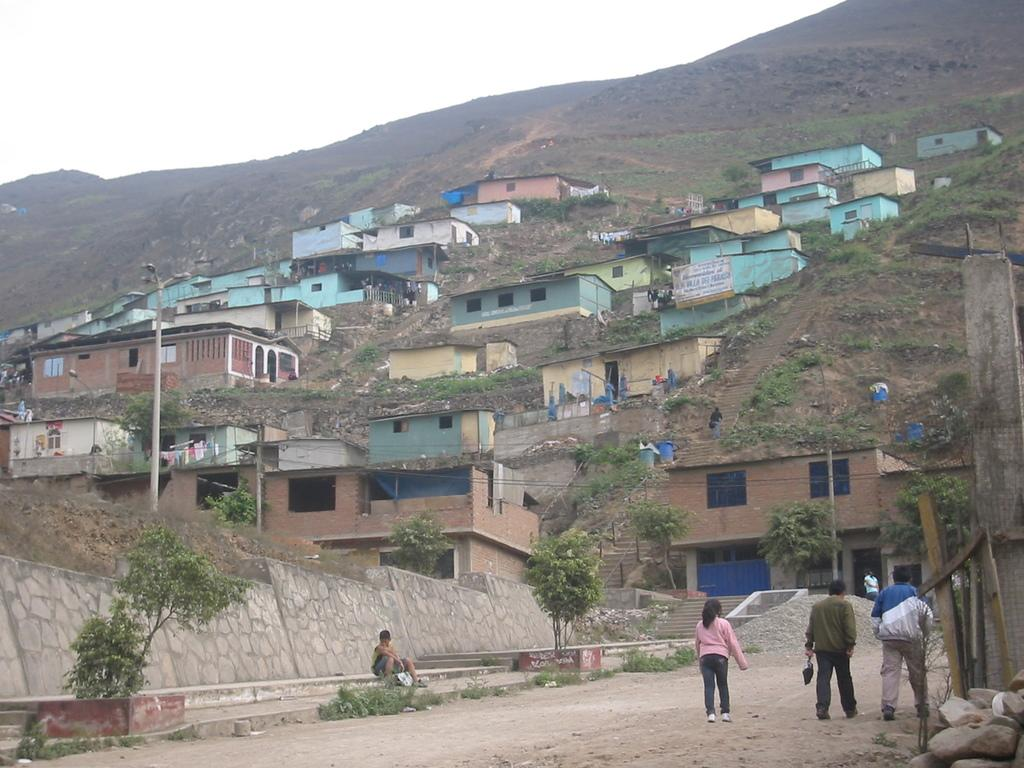What can be seen on the ground in the image? There are people on the ground in the image. What type of structures are visible in the image? There are houses in the image. What other natural elements can be seen in the image? There are trees in the image. What man-made objects are present in the image? There are poles in the image. Can you describe any other objects in the image? There are other objects in the image, but their specific details are not mentioned in the provided facts. What is visible in the background of the image? The sky is visible in the background of the image. Where is the throne located in the image? There is no throne present in the image. How many ants can be seen crawling on the people in the image? There are no ants visible in the image. 